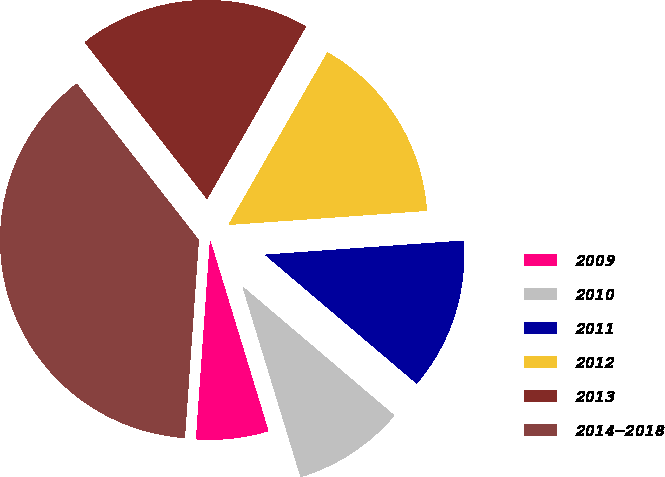<chart> <loc_0><loc_0><loc_500><loc_500><pie_chart><fcel>2009<fcel>2010<fcel>2011<fcel>2012<fcel>2013<fcel>2014-2018<nl><fcel>5.83%<fcel>9.08%<fcel>12.33%<fcel>15.58%<fcel>18.83%<fcel>38.33%<nl></chart> 